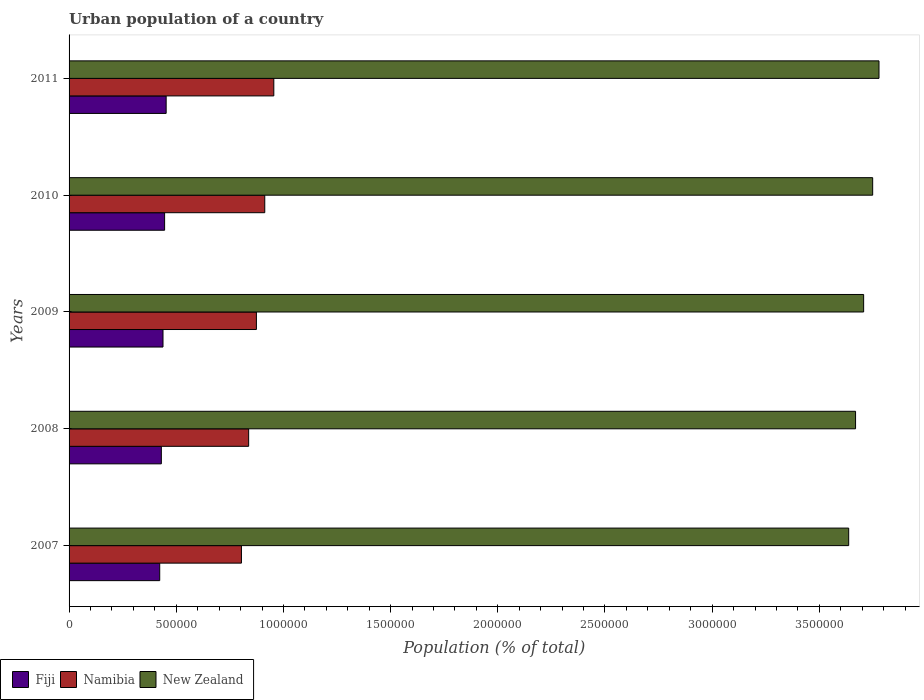How many different coloured bars are there?
Provide a succinct answer. 3. Are the number of bars per tick equal to the number of legend labels?
Offer a terse response. Yes. Are the number of bars on each tick of the Y-axis equal?
Offer a terse response. Yes. How many bars are there on the 5th tick from the top?
Your answer should be very brief. 3. What is the urban population in New Zealand in 2007?
Keep it short and to the point. 3.64e+06. Across all years, what is the maximum urban population in Namibia?
Offer a very short reply. 9.55e+05. Across all years, what is the minimum urban population in New Zealand?
Provide a short and direct response. 3.64e+06. What is the total urban population in Fiji in the graph?
Make the answer very short. 2.19e+06. What is the difference between the urban population in Fiji in 2010 and that in 2011?
Provide a short and direct response. -7170. What is the difference between the urban population in New Zealand in 2011 and the urban population in Namibia in 2007?
Keep it short and to the point. 2.97e+06. What is the average urban population in New Zealand per year?
Your response must be concise. 3.71e+06. In the year 2010, what is the difference between the urban population in New Zealand and urban population in Namibia?
Provide a succinct answer. 2.84e+06. What is the ratio of the urban population in Namibia in 2007 to that in 2010?
Offer a very short reply. 0.88. Is the urban population in Fiji in 2007 less than that in 2009?
Your answer should be very brief. Yes. Is the difference between the urban population in New Zealand in 2008 and 2009 greater than the difference between the urban population in Namibia in 2008 and 2009?
Your answer should be very brief. No. What is the difference between the highest and the second highest urban population in Namibia?
Make the answer very short. 4.22e+04. What is the difference between the highest and the lowest urban population in Fiji?
Provide a succinct answer. 3.00e+04. In how many years, is the urban population in New Zealand greater than the average urban population in New Zealand taken over all years?
Keep it short and to the point. 2. What does the 3rd bar from the top in 2011 represents?
Your answer should be compact. Fiji. What does the 2nd bar from the bottom in 2010 represents?
Provide a short and direct response. Namibia. Is it the case that in every year, the sum of the urban population in New Zealand and urban population in Namibia is greater than the urban population in Fiji?
Give a very brief answer. Yes. How many bars are there?
Ensure brevity in your answer.  15. How many years are there in the graph?
Provide a short and direct response. 5. What is the difference between two consecutive major ticks on the X-axis?
Provide a succinct answer. 5.00e+05. Are the values on the major ticks of X-axis written in scientific E-notation?
Ensure brevity in your answer.  No. Does the graph contain any zero values?
Your answer should be compact. No. Does the graph contain grids?
Give a very brief answer. No. Where does the legend appear in the graph?
Offer a very short reply. Bottom left. What is the title of the graph?
Provide a short and direct response. Urban population of a country. Does "Kenya" appear as one of the legend labels in the graph?
Your response must be concise. No. What is the label or title of the X-axis?
Give a very brief answer. Population (% of total). What is the label or title of the Y-axis?
Make the answer very short. Years. What is the Population (% of total) of Fiji in 2007?
Your answer should be very brief. 4.23e+05. What is the Population (% of total) of Namibia in 2007?
Your answer should be very brief. 8.04e+05. What is the Population (% of total) of New Zealand in 2007?
Your answer should be very brief. 3.64e+06. What is the Population (% of total) of Fiji in 2008?
Offer a very short reply. 4.30e+05. What is the Population (% of total) of Namibia in 2008?
Your answer should be compact. 8.38e+05. What is the Population (% of total) of New Zealand in 2008?
Provide a short and direct response. 3.67e+06. What is the Population (% of total) of Fiji in 2009?
Your answer should be compact. 4.38e+05. What is the Population (% of total) in Namibia in 2009?
Ensure brevity in your answer.  8.74e+05. What is the Population (% of total) in New Zealand in 2009?
Make the answer very short. 3.71e+06. What is the Population (% of total) of Fiji in 2010?
Your answer should be very brief. 4.46e+05. What is the Population (% of total) of Namibia in 2010?
Provide a succinct answer. 9.13e+05. What is the Population (% of total) of New Zealand in 2010?
Your answer should be very brief. 3.75e+06. What is the Population (% of total) in Fiji in 2011?
Make the answer very short. 4.53e+05. What is the Population (% of total) in Namibia in 2011?
Your answer should be compact. 9.55e+05. What is the Population (% of total) in New Zealand in 2011?
Your answer should be compact. 3.78e+06. Across all years, what is the maximum Population (% of total) of Fiji?
Ensure brevity in your answer.  4.53e+05. Across all years, what is the maximum Population (% of total) of Namibia?
Provide a succinct answer. 9.55e+05. Across all years, what is the maximum Population (% of total) of New Zealand?
Offer a very short reply. 3.78e+06. Across all years, what is the minimum Population (% of total) of Fiji?
Offer a terse response. 4.23e+05. Across all years, what is the minimum Population (% of total) in Namibia?
Your response must be concise. 8.04e+05. Across all years, what is the minimum Population (% of total) in New Zealand?
Offer a very short reply. 3.64e+06. What is the total Population (% of total) in Fiji in the graph?
Give a very brief answer. 2.19e+06. What is the total Population (% of total) in Namibia in the graph?
Your response must be concise. 4.38e+06. What is the total Population (% of total) in New Zealand in the graph?
Your response must be concise. 1.85e+07. What is the difference between the Population (% of total) of Fiji in 2007 and that in 2008?
Offer a terse response. -7616. What is the difference between the Population (% of total) of Namibia in 2007 and that in 2008?
Offer a terse response. -3.37e+04. What is the difference between the Population (% of total) in New Zealand in 2007 and that in 2008?
Make the answer very short. -3.21e+04. What is the difference between the Population (% of total) of Fiji in 2007 and that in 2009?
Give a very brief answer. -1.53e+04. What is the difference between the Population (% of total) of Namibia in 2007 and that in 2009?
Provide a succinct answer. -6.98e+04. What is the difference between the Population (% of total) in New Zealand in 2007 and that in 2009?
Ensure brevity in your answer.  -6.97e+04. What is the difference between the Population (% of total) of Fiji in 2007 and that in 2010?
Offer a terse response. -2.28e+04. What is the difference between the Population (% of total) of Namibia in 2007 and that in 2010?
Give a very brief answer. -1.09e+05. What is the difference between the Population (% of total) in New Zealand in 2007 and that in 2010?
Offer a terse response. -1.12e+05. What is the difference between the Population (% of total) of Fiji in 2007 and that in 2011?
Make the answer very short. -3.00e+04. What is the difference between the Population (% of total) in Namibia in 2007 and that in 2011?
Provide a succinct answer. -1.51e+05. What is the difference between the Population (% of total) of New Zealand in 2007 and that in 2011?
Keep it short and to the point. -1.41e+05. What is the difference between the Population (% of total) in Fiji in 2008 and that in 2009?
Give a very brief answer. -7729. What is the difference between the Population (% of total) in Namibia in 2008 and that in 2009?
Ensure brevity in your answer.  -3.61e+04. What is the difference between the Population (% of total) in New Zealand in 2008 and that in 2009?
Your answer should be very brief. -3.76e+04. What is the difference between the Population (% of total) in Fiji in 2008 and that in 2010?
Make the answer very short. -1.52e+04. What is the difference between the Population (% of total) in Namibia in 2008 and that in 2010?
Give a very brief answer. -7.52e+04. What is the difference between the Population (% of total) in New Zealand in 2008 and that in 2010?
Your response must be concise. -7.98e+04. What is the difference between the Population (% of total) in Fiji in 2008 and that in 2011?
Ensure brevity in your answer.  -2.24e+04. What is the difference between the Population (% of total) in Namibia in 2008 and that in 2011?
Offer a very short reply. -1.17e+05. What is the difference between the Population (% of total) of New Zealand in 2008 and that in 2011?
Ensure brevity in your answer.  -1.09e+05. What is the difference between the Population (% of total) of Fiji in 2009 and that in 2010?
Offer a terse response. -7502. What is the difference between the Population (% of total) in Namibia in 2009 and that in 2010?
Offer a terse response. -3.90e+04. What is the difference between the Population (% of total) of New Zealand in 2009 and that in 2010?
Your response must be concise. -4.22e+04. What is the difference between the Population (% of total) of Fiji in 2009 and that in 2011?
Keep it short and to the point. -1.47e+04. What is the difference between the Population (% of total) in Namibia in 2009 and that in 2011?
Provide a short and direct response. -8.13e+04. What is the difference between the Population (% of total) of New Zealand in 2009 and that in 2011?
Offer a very short reply. -7.17e+04. What is the difference between the Population (% of total) in Fiji in 2010 and that in 2011?
Ensure brevity in your answer.  -7170. What is the difference between the Population (% of total) of Namibia in 2010 and that in 2011?
Ensure brevity in your answer.  -4.22e+04. What is the difference between the Population (% of total) of New Zealand in 2010 and that in 2011?
Make the answer very short. -2.95e+04. What is the difference between the Population (% of total) in Fiji in 2007 and the Population (% of total) in Namibia in 2008?
Ensure brevity in your answer.  -4.15e+05. What is the difference between the Population (% of total) of Fiji in 2007 and the Population (% of total) of New Zealand in 2008?
Provide a short and direct response. -3.25e+06. What is the difference between the Population (% of total) in Namibia in 2007 and the Population (% of total) in New Zealand in 2008?
Give a very brief answer. -2.86e+06. What is the difference between the Population (% of total) of Fiji in 2007 and the Population (% of total) of Namibia in 2009?
Your answer should be compact. -4.51e+05. What is the difference between the Population (% of total) of Fiji in 2007 and the Population (% of total) of New Zealand in 2009?
Give a very brief answer. -3.28e+06. What is the difference between the Population (% of total) of Namibia in 2007 and the Population (% of total) of New Zealand in 2009?
Offer a terse response. -2.90e+06. What is the difference between the Population (% of total) of Fiji in 2007 and the Population (% of total) of Namibia in 2010?
Your answer should be very brief. -4.90e+05. What is the difference between the Population (% of total) of Fiji in 2007 and the Population (% of total) of New Zealand in 2010?
Make the answer very short. -3.33e+06. What is the difference between the Population (% of total) of Namibia in 2007 and the Population (% of total) of New Zealand in 2010?
Provide a short and direct response. -2.94e+06. What is the difference between the Population (% of total) of Fiji in 2007 and the Population (% of total) of Namibia in 2011?
Your answer should be very brief. -5.32e+05. What is the difference between the Population (% of total) in Fiji in 2007 and the Population (% of total) in New Zealand in 2011?
Offer a terse response. -3.36e+06. What is the difference between the Population (% of total) of Namibia in 2007 and the Population (% of total) of New Zealand in 2011?
Provide a short and direct response. -2.97e+06. What is the difference between the Population (% of total) of Fiji in 2008 and the Population (% of total) of Namibia in 2009?
Your response must be concise. -4.43e+05. What is the difference between the Population (% of total) in Fiji in 2008 and the Population (% of total) in New Zealand in 2009?
Ensure brevity in your answer.  -3.28e+06. What is the difference between the Population (% of total) in Namibia in 2008 and the Population (% of total) in New Zealand in 2009?
Your answer should be compact. -2.87e+06. What is the difference between the Population (% of total) in Fiji in 2008 and the Population (% of total) in Namibia in 2010?
Give a very brief answer. -4.82e+05. What is the difference between the Population (% of total) of Fiji in 2008 and the Population (% of total) of New Zealand in 2010?
Offer a very short reply. -3.32e+06. What is the difference between the Population (% of total) in Namibia in 2008 and the Population (% of total) in New Zealand in 2010?
Provide a succinct answer. -2.91e+06. What is the difference between the Population (% of total) of Fiji in 2008 and the Population (% of total) of Namibia in 2011?
Your response must be concise. -5.25e+05. What is the difference between the Population (% of total) of Fiji in 2008 and the Population (% of total) of New Zealand in 2011?
Offer a terse response. -3.35e+06. What is the difference between the Population (% of total) of Namibia in 2008 and the Population (% of total) of New Zealand in 2011?
Keep it short and to the point. -2.94e+06. What is the difference between the Population (% of total) in Fiji in 2009 and the Population (% of total) in Namibia in 2010?
Make the answer very short. -4.75e+05. What is the difference between the Population (% of total) in Fiji in 2009 and the Population (% of total) in New Zealand in 2010?
Ensure brevity in your answer.  -3.31e+06. What is the difference between the Population (% of total) in Namibia in 2009 and the Population (% of total) in New Zealand in 2010?
Your answer should be compact. -2.87e+06. What is the difference between the Population (% of total) of Fiji in 2009 and the Population (% of total) of Namibia in 2011?
Give a very brief answer. -5.17e+05. What is the difference between the Population (% of total) in Fiji in 2009 and the Population (% of total) in New Zealand in 2011?
Your response must be concise. -3.34e+06. What is the difference between the Population (% of total) of Namibia in 2009 and the Population (% of total) of New Zealand in 2011?
Your answer should be very brief. -2.90e+06. What is the difference between the Population (% of total) of Fiji in 2010 and the Population (% of total) of Namibia in 2011?
Your answer should be very brief. -5.09e+05. What is the difference between the Population (% of total) of Fiji in 2010 and the Population (% of total) of New Zealand in 2011?
Your answer should be compact. -3.33e+06. What is the difference between the Population (% of total) in Namibia in 2010 and the Population (% of total) in New Zealand in 2011?
Offer a terse response. -2.87e+06. What is the average Population (% of total) in Fiji per year?
Provide a short and direct response. 4.38e+05. What is the average Population (% of total) of Namibia per year?
Offer a terse response. 8.77e+05. What is the average Population (% of total) in New Zealand per year?
Offer a very short reply. 3.71e+06. In the year 2007, what is the difference between the Population (% of total) in Fiji and Population (% of total) in Namibia?
Provide a succinct answer. -3.81e+05. In the year 2007, what is the difference between the Population (% of total) in Fiji and Population (% of total) in New Zealand?
Offer a very short reply. -3.21e+06. In the year 2007, what is the difference between the Population (% of total) in Namibia and Population (% of total) in New Zealand?
Give a very brief answer. -2.83e+06. In the year 2008, what is the difference between the Population (% of total) in Fiji and Population (% of total) in Namibia?
Provide a succinct answer. -4.07e+05. In the year 2008, what is the difference between the Population (% of total) in Fiji and Population (% of total) in New Zealand?
Your answer should be very brief. -3.24e+06. In the year 2008, what is the difference between the Population (% of total) of Namibia and Population (% of total) of New Zealand?
Provide a short and direct response. -2.83e+06. In the year 2009, what is the difference between the Population (% of total) of Fiji and Population (% of total) of Namibia?
Give a very brief answer. -4.36e+05. In the year 2009, what is the difference between the Population (% of total) in Fiji and Population (% of total) in New Zealand?
Provide a succinct answer. -3.27e+06. In the year 2009, what is the difference between the Population (% of total) in Namibia and Population (% of total) in New Zealand?
Your response must be concise. -2.83e+06. In the year 2010, what is the difference between the Population (% of total) of Fiji and Population (% of total) of Namibia?
Your response must be concise. -4.67e+05. In the year 2010, what is the difference between the Population (% of total) of Fiji and Population (% of total) of New Zealand?
Keep it short and to the point. -3.30e+06. In the year 2010, what is the difference between the Population (% of total) of Namibia and Population (% of total) of New Zealand?
Give a very brief answer. -2.84e+06. In the year 2011, what is the difference between the Population (% of total) of Fiji and Population (% of total) of Namibia?
Make the answer very short. -5.02e+05. In the year 2011, what is the difference between the Population (% of total) of Fiji and Population (% of total) of New Zealand?
Provide a succinct answer. -3.33e+06. In the year 2011, what is the difference between the Population (% of total) of Namibia and Population (% of total) of New Zealand?
Ensure brevity in your answer.  -2.82e+06. What is the ratio of the Population (% of total) of Fiji in 2007 to that in 2008?
Ensure brevity in your answer.  0.98. What is the ratio of the Population (% of total) in Namibia in 2007 to that in 2008?
Provide a short and direct response. 0.96. What is the ratio of the Population (% of total) in Namibia in 2007 to that in 2009?
Your answer should be very brief. 0.92. What is the ratio of the Population (% of total) of New Zealand in 2007 to that in 2009?
Keep it short and to the point. 0.98. What is the ratio of the Population (% of total) in Fiji in 2007 to that in 2010?
Your answer should be compact. 0.95. What is the ratio of the Population (% of total) of Namibia in 2007 to that in 2010?
Provide a succinct answer. 0.88. What is the ratio of the Population (% of total) in New Zealand in 2007 to that in 2010?
Keep it short and to the point. 0.97. What is the ratio of the Population (% of total) in Fiji in 2007 to that in 2011?
Offer a very short reply. 0.93. What is the ratio of the Population (% of total) of Namibia in 2007 to that in 2011?
Your response must be concise. 0.84. What is the ratio of the Population (% of total) in New Zealand in 2007 to that in 2011?
Offer a very short reply. 0.96. What is the ratio of the Population (% of total) in Fiji in 2008 to that in 2009?
Your answer should be very brief. 0.98. What is the ratio of the Population (% of total) of Namibia in 2008 to that in 2009?
Your response must be concise. 0.96. What is the ratio of the Population (% of total) in Fiji in 2008 to that in 2010?
Keep it short and to the point. 0.97. What is the ratio of the Population (% of total) of Namibia in 2008 to that in 2010?
Provide a short and direct response. 0.92. What is the ratio of the Population (% of total) in New Zealand in 2008 to that in 2010?
Provide a short and direct response. 0.98. What is the ratio of the Population (% of total) of Fiji in 2008 to that in 2011?
Your answer should be very brief. 0.95. What is the ratio of the Population (% of total) of Namibia in 2008 to that in 2011?
Keep it short and to the point. 0.88. What is the ratio of the Population (% of total) in New Zealand in 2008 to that in 2011?
Offer a terse response. 0.97. What is the ratio of the Population (% of total) of Fiji in 2009 to that in 2010?
Make the answer very short. 0.98. What is the ratio of the Population (% of total) in Namibia in 2009 to that in 2010?
Ensure brevity in your answer.  0.96. What is the ratio of the Population (% of total) in New Zealand in 2009 to that in 2010?
Offer a terse response. 0.99. What is the ratio of the Population (% of total) of Fiji in 2009 to that in 2011?
Your answer should be very brief. 0.97. What is the ratio of the Population (% of total) of Namibia in 2009 to that in 2011?
Offer a terse response. 0.91. What is the ratio of the Population (% of total) in New Zealand in 2009 to that in 2011?
Provide a succinct answer. 0.98. What is the ratio of the Population (% of total) of Fiji in 2010 to that in 2011?
Provide a short and direct response. 0.98. What is the ratio of the Population (% of total) of Namibia in 2010 to that in 2011?
Give a very brief answer. 0.96. What is the difference between the highest and the second highest Population (% of total) in Fiji?
Your answer should be compact. 7170. What is the difference between the highest and the second highest Population (% of total) in Namibia?
Your answer should be very brief. 4.22e+04. What is the difference between the highest and the second highest Population (% of total) in New Zealand?
Offer a terse response. 2.95e+04. What is the difference between the highest and the lowest Population (% of total) in Fiji?
Offer a very short reply. 3.00e+04. What is the difference between the highest and the lowest Population (% of total) of Namibia?
Ensure brevity in your answer.  1.51e+05. What is the difference between the highest and the lowest Population (% of total) of New Zealand?
Ensure brevity in your answer.  1.41e+05. 